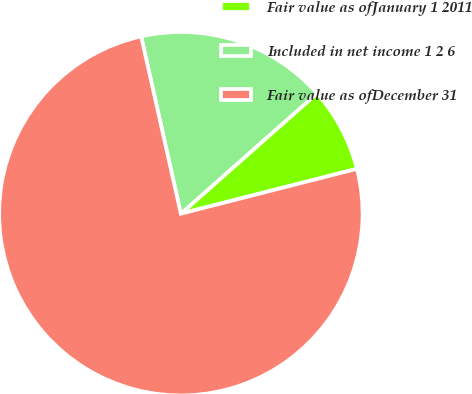Convert chart to OTSL. <chart><loc_0><loc_0><loc_500><loc_500><pie_chart><fcel>Fair value as ofJanuary 1 2011<fcel>Included in net income 1 2 6<fcel>Fair value as ofDecember 31<nl><fcel>7.55%<fcel>16.98%<fcel>75.47%<nl></chart> 